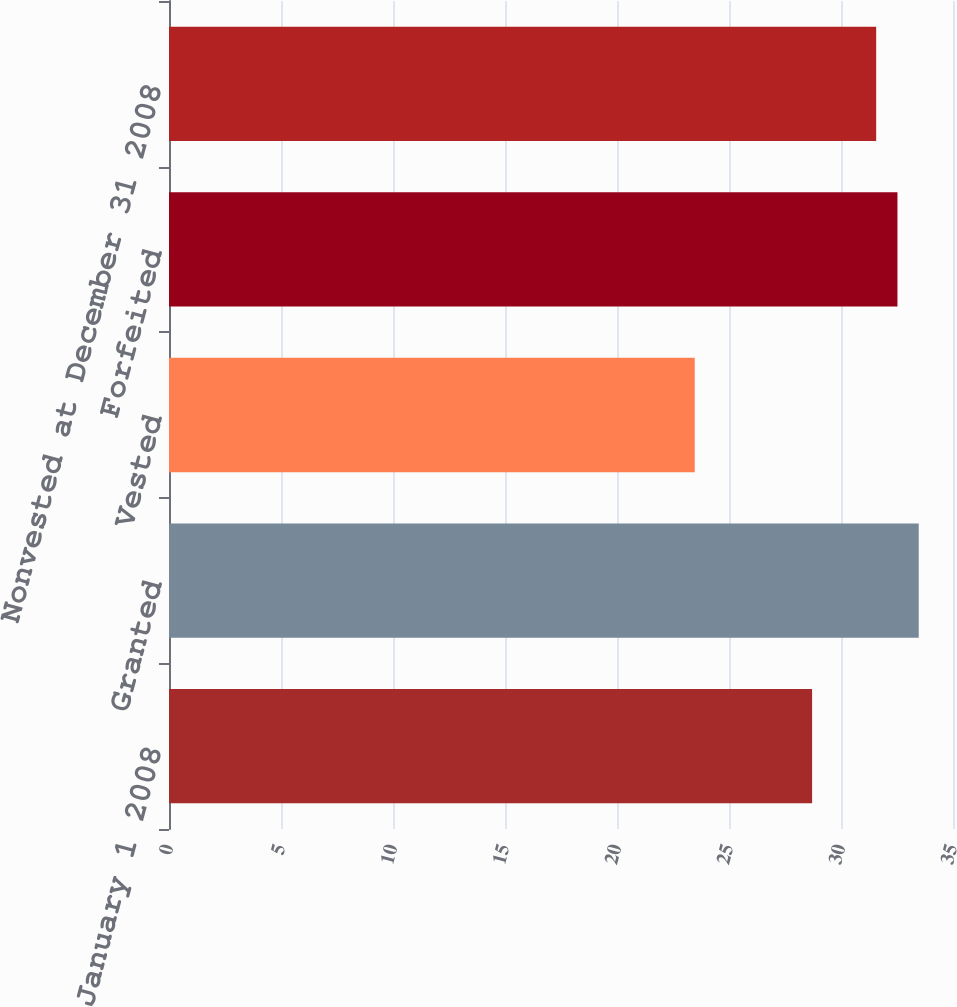<chart> <loc_0><loc_0><loc_500><loc_500><bar_chart><fcel>Nonvested at January 1 2008<fcel>Granted<fcel>Vested<fcel>Forfeited<fcel>Nonvested at December 31 2008<nl><fcel>28.71<fcel>33.47<fcel>23.47<fcel>32.52<fcel>31.57<nl></chart> 